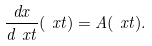Convert formula to latex. <formula><loc_0><loc_0><loc_500><loc_500>\frac { d x } { d \ x t } ( \ x t ) = A ( \ x t ) .</formula> 